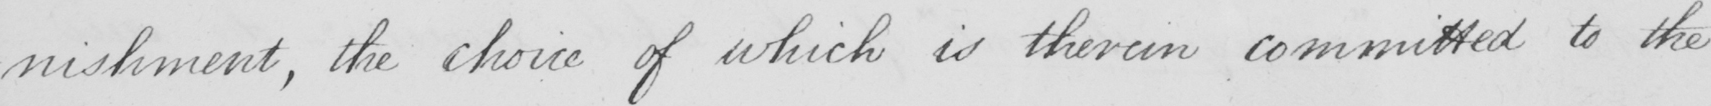Transcribe the text shown in this historical manuscript line. -nishment , the choice of which is therein committed to the 